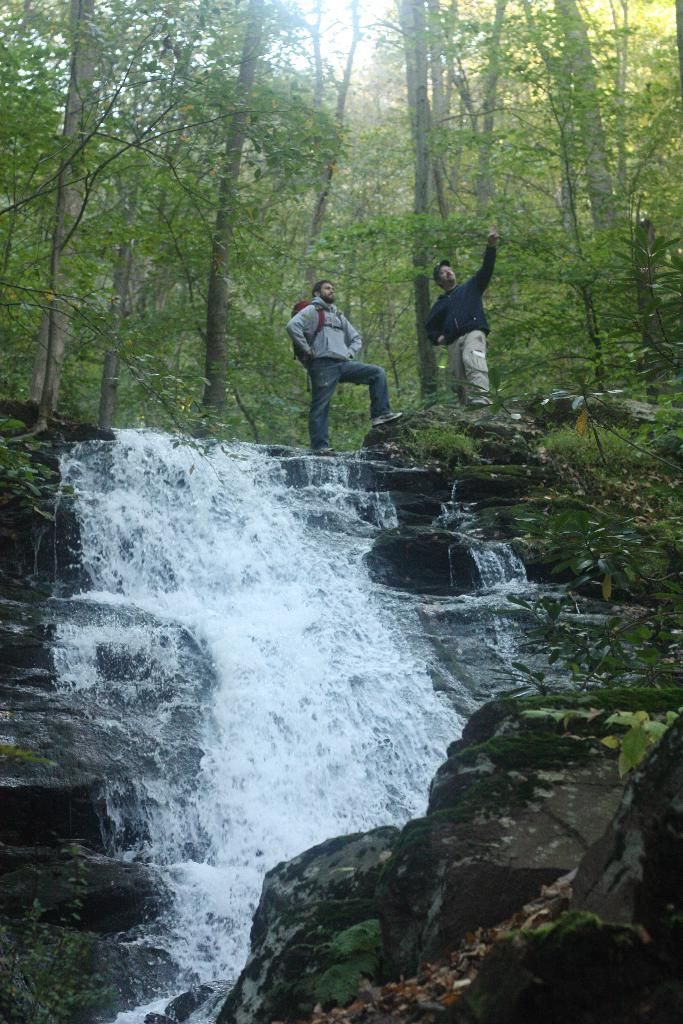How many people are in the image? There are two persons in the image. Can you describe what one of the persons is carrying? One of the persons is wearing a backpack. What type of natural environment is depicted in the image? The image features trees, plants, grass, and water flowing through rocks. What part of the sky is visible in the image? The sky is visible in the image. What type of coil is being used by the group of dolls in the image? There are no dolls or coils present in the image. How many dolls are sitting on the grass in the image? There are no dolls present in the image. 